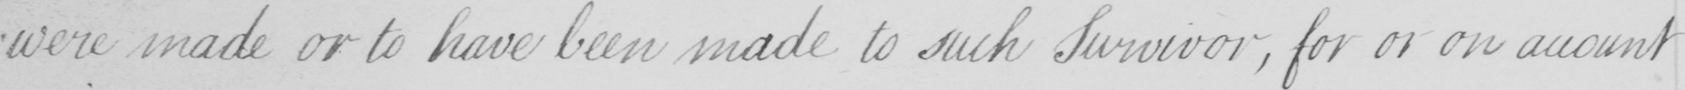Please transcribe the handwritten text in this image. were made or to have been made to such Survivor , for or on account 